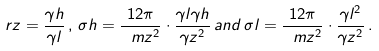Convert formula to latex. <formula><loc_0><loc_0><loc_500><loc_500>\ r z = \frac { \gamma h } { \gamma l } \, , \, \sigma h = \frac { 1 2 \pi } { \ m z ^ { 2 } } \cdot \frac { \gamma l \gamma h } { \gamma z ^ { 2 } } \, a n d \, \sigma l = \frac { 1 2 \pi } { \ m z ^ { 2 } } \cdot \frac { \gamma l ^ { 2 } } { \gamma z ^ { 2 } } \, .</formula> 